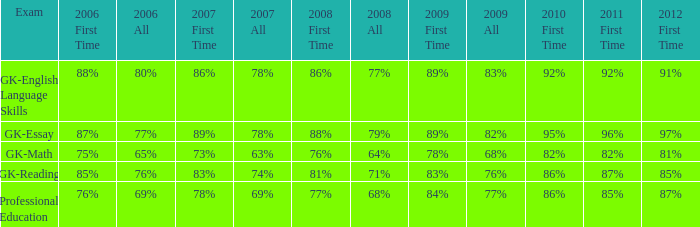What is the percentage for all in 2008 when all in 2007 was 69%? 68%. 